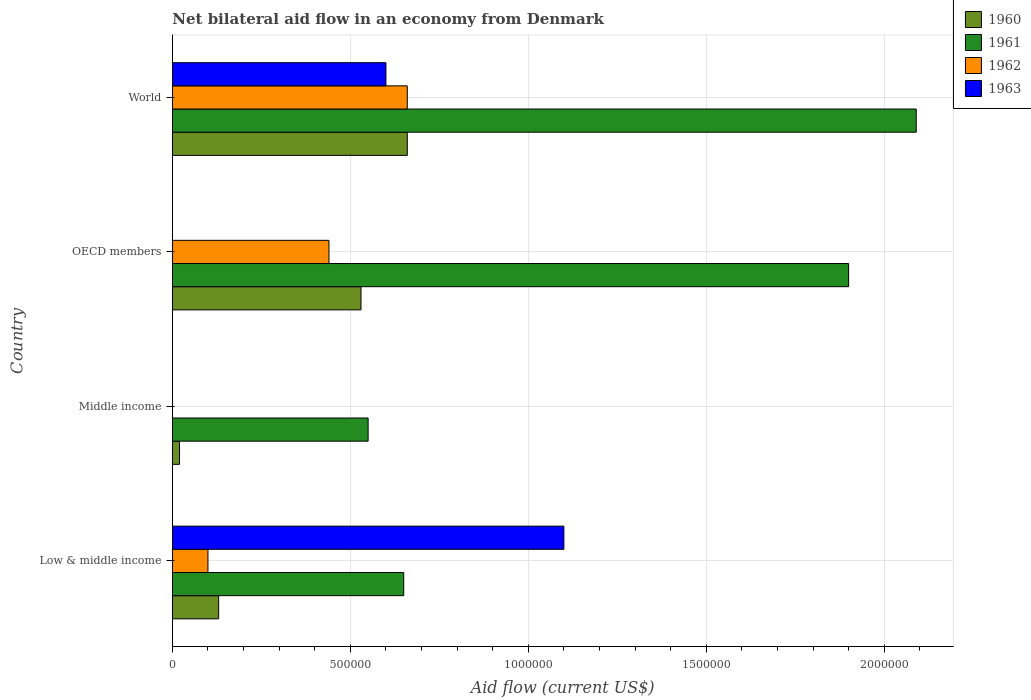Are the number of bars per tick equal to the number of legend labels?
Your response must be concise. No. What is the label of the 2nd group of bars from the top?
Provide a succinct answer. OECD members. What is the net bilateral aid flow in 1961 in OECD members?
Your answer should be very brief. 1.90e+06. Across all countries, what is the maximum net bilateral aid flow in 1962?
Offer a very short reply. 6.60e+05. Across all countries, what is the minimum net bilateral aid flow in 1962?
Ensure brevity in your answer.  0. What is the total net bilateral aid flow in 1960 in the graph?
Your answer should be very brief. 1.34e+06. What is the difference between the net bilateral aid flow in 1960 in Middle income and that in OECD members?
Give a very brief answer. -5.10e+05. What is the difference between the net bilateral aid flow in 1961 in Middle income and the net bilateral aid flow in 1962 in Low & middle income?
Keep it short and to the point. 4.50e+05. What is the difference between the net bilateral aid flow in 1962 and net bilateral aid flow in 1960 in World?
Provide a succinct answer. 0. What is the ratio of the net bilateral aid flow in 1962 in Low & middle income to that in OECD members?
Offer a terse response. 0.23. Is the difference between the net bilateral aid flow in 1962 in Low & middle income and OECD members greater than the difference between the net bilateral aid flow in 1960 in Low & middle income and OECD members?
Keep it short and to the point. Yes. What is the difference between the highest and the second highest net bilateral aid flow in 1962?
Provide a short and direct response. 2.20e+05. What is the difference between the highest and the lowest net bilateral aid flow in 1963?
Provide a succinct answer. 1.10e+06. In how many countries, is the net bilateral aid flow in 1962 greater than the average net bilateral aid flow in 1962 taken over all countries?
Your answer should be very brief. 2. Is it the case that in every country, the sum of the net bilateral aid flow in 1962 and net bilateral aid flow in 1961 is greater than the sum of net bilateral aid flow in 1963 and net bilateral aid flow in 1960?
Your answer should be very brief. No. Is it the case that in every country, the sum of the net bilateral aid flow in 1960 and net bilateral aid flow in 1961 is greater than the net bilateral aid flow in 1963?
Your answer should be compact. No. How many countries are there in the graph?
Give a very brief answer. 4. What is the difference between two consecutive major ticks on the X-axis?
Provide a succinct answer. 5.00e+05. How many legend labels are there?
Keep it short and to the point. 4. How are the legend labels stacked?
Your answer should be compact. Vertical. What is the title of the graph?
Ensure brevity in your answer.  Net bilateral aid flow in an economy from Denmark. What is the label or title of the X-axis?
Provide a short and direct response. Aid flow (current US$). What is the label or title of the Y-axis?
Ensure brevity in your answer.  Country. What is the Aid flow (current US$) in 1960 in Low & middle income?
Keep it short and to the point. 1.30e+05. What is the Aid flow (current US$) in 1961 in Low & middle income?
Give a very brief answer. 6.50e+05. What is the Aid flow (current US$) in 1962 in Low & middle income?
Provide a short and direct response. 1.00e+05. What is the Aid flow (current US$) of 1963 in Low & middle income?
Your answer should be compact. 1.10e+06. What is the Aid flow (current US$) of 1960 in Middle income?
Keep it short and to the point. 2.00e+04. What is the Aid flow (current US$) of 1960 in OECD members?
Your answer should be very brief. 5.30e+05. What is the Aid flow (current US$) of 1961 in OECD members?
Ensure brevity in your answer.  1.90e+06. What is the Aid flow (current US$) of 1963 in OECD members?
Your response must be concise. 0. What is the Aid flow (current US$) of 1960 in World?
Your response must be concise. 6.60e+05. What is the Aid flow (current US$) of 1961 in World?
Keep it short and to the point. 2.09e+06. What is the Aid flow (current US$) in 1962 in World?
Offer a very short reply. 6.60e+05. Across all countries, what is the maximum Aid flow (current US$) of 1960?
Provide a succinct answer. 6.60e+05. Across all countries, what is the maximum Aid flow (current US$) of 1961?
Your response must be concise. 2.09e+06. Across all countries, what is the maximum Aid flow (current US$) of 1963?
Provide a succinct answer. 1.10e+06. Across all countries, what is the minimum Aid flow (current US$) of 1961?
Your answer should be very brief. 5.50e+05. Across all countries, what is the minimum Aid flow (current US$) of 1962?
Your answer should be very brief. 0. What is the total Aid flow (current US$) of 1960 in the graph?
Your response must be concise. 1.34e+06. What is the total Aid flow (current US$) of 1961 in the graph?
Offer a very short reply. 5.19e+06. What is the total Aid flow (current US$) of 1962 in the graph?
Give a very brief answer. 1.20e+06. What is the total Aid flow (current US$) of 1963 in the graph?
Keep it short and to the point. 1.70e+06. What is the difference between the Aid flow (current US$) of 1960 in Low & middle income and that in OECD members?
Make the answer very short. -4.00e+05. What is the difference between the Aid flow (current US$) of 1961 in Low & middle income and that in OECD members?
Give a very brief answer. -1.25e+06. What is the difference between the Aid flow (current US$) of 1962 in Low & middle income and that in OECD members?
Your answer should be very brief. -3.40e+05. What is the difference between the Aid flow (current US$) of 1960 in Low & middle income and that in World?
Offer a terse response. -5.30e+05. What is the difference between the Aid flow (current US$) in 1961 in Low & middle income and that in World?
Give a very brief answer. -1.44e+06. What is the difference between the Aid flow (current US$) in 1962 in Low & middle income and that in World?
Provide a short and direct response. -5.60e+05. What is the difference between the Aid flow (current US$) of 1960 in Middle income and that in OECD members?
Make the answer very short. -5.10e+05. What is the difference between the Aid flow (current US$) in 1961 in Middle income and that in OECD members?
Your answer should be compact. -1.35e+06. What is the difference between the Aid flow (current US$) of 1960 in Middle income and that in World?
Provide a short and direct response. -6.40e+05. What is the difference between the Aid flow (current US$) of 1961 in Middle income and that in World?
Ensure brevity in your answer.  -1.54e+06. What is the difference between the Aid flow (current US$) in 1961 in OECD members and that in World?
Your response must be concise. -1.90e+05. What is the difference between the Aid flow (current US$) in 1960 in Low & middle income and the Aid flow (current US$) in 1961 in Middle income?
Keep it short and to the point. -4.20e+05. What is the difference between the Aid flow (current US$) of 1960 in Low & middle income and the Aid flow (current US$) of 1961 in OECD members?
Provide a short and direct response. -1.77e+06. What is the difference between the Aid flow (current US$) in 1960 in Low & middle income and the Aid flow (current US$) in 1962 in OECD members?
Provide a short and direct response. -3.10e+05. What is the difference between the Aid flow (current US$) of 1961 in Low & middle income and the Aid flow (current US$) of 1962 in OECD members?
Offer a very short reply. 2.10e+05. What is the difference between the Aid flow (current US$) in 1960 in Low & middle income and the Aid flow (current US$) in 1961 in World?
Your answer should be very brief. -1.96e+06. What is the difference between the Aid flow (current US$) in 1960 in Low & middle income and the Aid flow (current US$) in 1962 in World?
Keep it short and to the point. -5.30e+05. What is the difference between the Aid flow (current US$) in 1960 in Low & middle income and the Aid flow (current US$) in 1963 in World?
Ensure brevity in your answer.  -4.70e+05. What is the difference between the Aid flow (current US$) of 1962 in Low & middle income and the Aid flow (current US$) of 1963 in World?
Offer a very short reply. -5.00e+05. What is the difference between the Aid flow (current US$) of 1960 in Middle income and the Aid flow (current US$) of 1961 in OECD members?
Keep it short and to the point. -1.88e+06. What is the difference between the Aid flow (current US$) in 1960 in Middle income and the Aid flow (current US$) in 1962 in OECD members?
Ensure brevity in your answer.  -4.20e+05. What is the difference between the Aid flow (current US$) of 1961 in Middle income and the Aid flow (current US$) of 1962 in OECD members?
Make the answer very short. 1.10e+05. What is the difference between the Aid flow (current US$) of 1960 in Middle income and the Aid flow (current US$) of 1961 in World?
Your answer should be very brief. -2.07e+06. What is the difference between the Aid flow (current US$) in 1960 in Middle income and the Aid flow (current US$) in 1962 in World?
Offer a very short reply. -6.40e+05. What is the difference between the Aid flow (current US$) of 1960 in Middle income and the Aid flow (current US$) of 1963 in World?
Keep it short and to the point. -5.80e+05. What is the difference between the Aid flow (current US$) of 1961 in Middle income and the Aid flow (current US$) of 1963 in World?
Your response must be concise. -5.00e+04. What is the difference between the Aid flow (current US$) of 1960 in OECD members and the Aid flow (current US$) of 1961 in World?
Your response must be concise. -1.56e+06. What is the difference between the Aid flow (current US$) of 1960 in OECD members and the Aid flow (current US$) of 1962 in World?
Keep it short and to the point. -1.30e+05. What is the difference between the Aid flow (current US$) of 1960 in OECD members and the Aid flow (current US$) of 1963 in World?
Provide a short and direct response. -7.00e+04. What is the difference between the Aid flow (current US$) of 1961 in OECD members and the Aid flow (current US$) of 1962 in World?
Give a very brief answer. 1.24e+06. What is the difference between the Aid flow (current US$) in 1961 in OECD members and the Aid flow (current US$) in 1963 in World?
Offer a very short reply. 1.30e+06. What is the difference between the Aid flow (current US$) of 1962 in OECD members and the Aid flow (current US$) of 1963 in World?
Offer a very short reply. -1.60e+05. What is the average Aid flow (current US$) in 1960 per country?
Your response must be concise. 3.35e+05. What is the average Aid flow (current US$) in 1961 per country?
Keep it short and to the point. 1.30e+06. What is the average Aid flow (current US$) of 1963 per country?
Ensure brevity in your answer.  4.25e+05. What is the difference between the Aid flow (current US$) of 1960 and Aid flow (current US$) of 1961 in Low & middle income?
Keep it short and to the point. -5.20e+05. What is the difference between the Aid flow (current US$) of 1960 and Aid flow (current US$) of 1962 in Low & middle income?
Give a very brief answer. 3.00e+04. What is the difference between the Aid flow (current US$) in 1960 and Aid flow (current US$) in 1963 in Low & middle income?
Your answer should be very brief. -9.70e+05. What is the difference between the Aid flow (current US$) of 1961 and Aid flow (current US$) of 1962 in Low & middle income?
Offer a very short reply. 5.50e+05. What is the difference between the Aid flow (current US$) of 1961 and Aid flow (current US$) of 1963 in Low & middle income?
Offer a very short reply. -4.50e+05. What is the difference between the Aid flow (current US$) of 1960 and Aid flow (current US$) of 1961 in Middle income?
Provide a succinct answer. -5.30e+05. What is the difference between the Aid flow (current US$) of 1960 and Aid flow (current US$) of 1961 in OECD members?
Make the answer very short. -1.37e+06. What is the difference between the Aid flow (current US$) of 1961 and Aid flow (current US$) of 1962 in OECD members?
Give a very brief answer. 1.46e+06. What is the difference between the Aid flow (current US$) in 1960 and Aid flow (current US$) in 1961 in World?
Make the answer very short. -1.43e+06. What is the difference between the Aid flow (current US$) in 1960 and Aid flow (current US$) in 1962 in World?
Your answer should be compact. 0. What is the difference between the Aid flow (current US$) of 1961 and Aid flow (current US$) of 1962 in World?
Offer a terse response. 1.43e+06. What is the difference between the Aid flow (current US$) of 1961 and Aid flow (current US$) of 1963 in World?
Provide a succinct answer. 1.49e+06. What is the ratio of the Aid flow (current US$) of 1961 in Low & middle income to that in Middle income?
Provide a succinct answer. 1.18. What is the ratio of the Aid flow (current US$) of 1960 in Low & middle income to that in OECD members?
Your answer should be compact. 0.25. What is the ratio of the Aid flow (current US$) in 1961 in Low & middle income to that in OECD members?
Give a very brief answer. 0.34. What is the ratio of the Aid flow (current US$) of 1962 in Low & middle income to that in OECD members?
Make the answer very short. 0.23. What is the ratio of the Aid flow (current US$) of 1960 in Low & middle income to that in World?
Provide a short and direct response. 0.2. What is the ratio of the Aid flow (current US$) of 1961 in Low & middle income to that in World?
Make the answer very short. 0.31. What is the ratio of the Aid flow (current US$) of 1962 in Low & middle income to that in World?
Make the answer very short. 0.15. What is the ratio of the Aid flow (current US$) in 1963 in Low & middle income to that in World?
Provide a succinct answer. 1.83. What is the ratio of the Aid flow (current US$) in 1960 in Middle income to that in OECD members?
Offer a terse response. 0.04. What is the ratio of the Aid flow (current US$) in 1961 in Middle income to that in OECD members?
Your response must be concise. 0.29. What is the ratio of the Aid flow (current US$) in 1960 in Middle income to that in World?
Provide a short and direct response. 0.03. What is the ratio of the Aid flow (current US$) in 1961 in Middle income to that in World?
Give a very brief answer. 0.26. What is the ratio of the Aid flow (current US$) of 1960 in OECD members to that in World?
Make the answer very short. 0.8. What is the difference between the highest and the second highest Aid flow (current US$) of 1961?
Ensure brevity in your answer.  1.90e+05. What is the difference between the highest and the lowest Aid flow (current US$) of 1960?
Make the answer very short. 6.40e+05. What is the difference between the highest and the lowest Aid flow (current US$) in 1961?
Give a very brief answer. 1.54e+06. What is the difference between the highest and the lowest Aid flow (current US$) of 1962?
Offer a very short reply. 6.60e+05. What is the difference between the highest and the lowest Aid flow (current US$) in 1963?
Your response must be concise. 1.10e+06. 